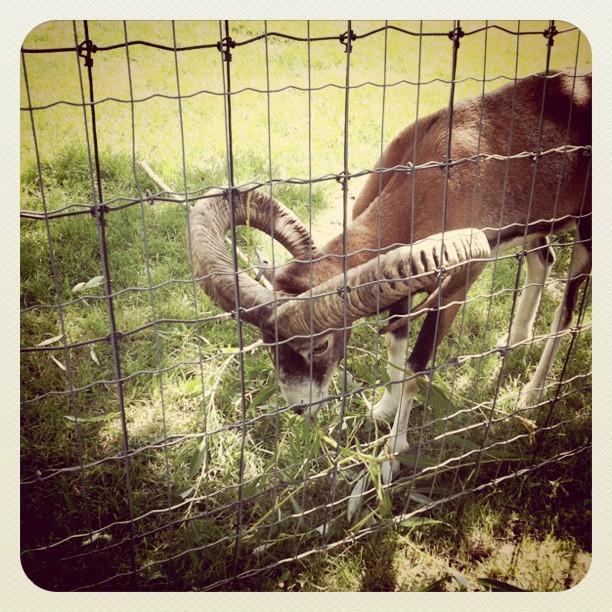How many fingers does the man have?
Give a very brief answer. 0. 